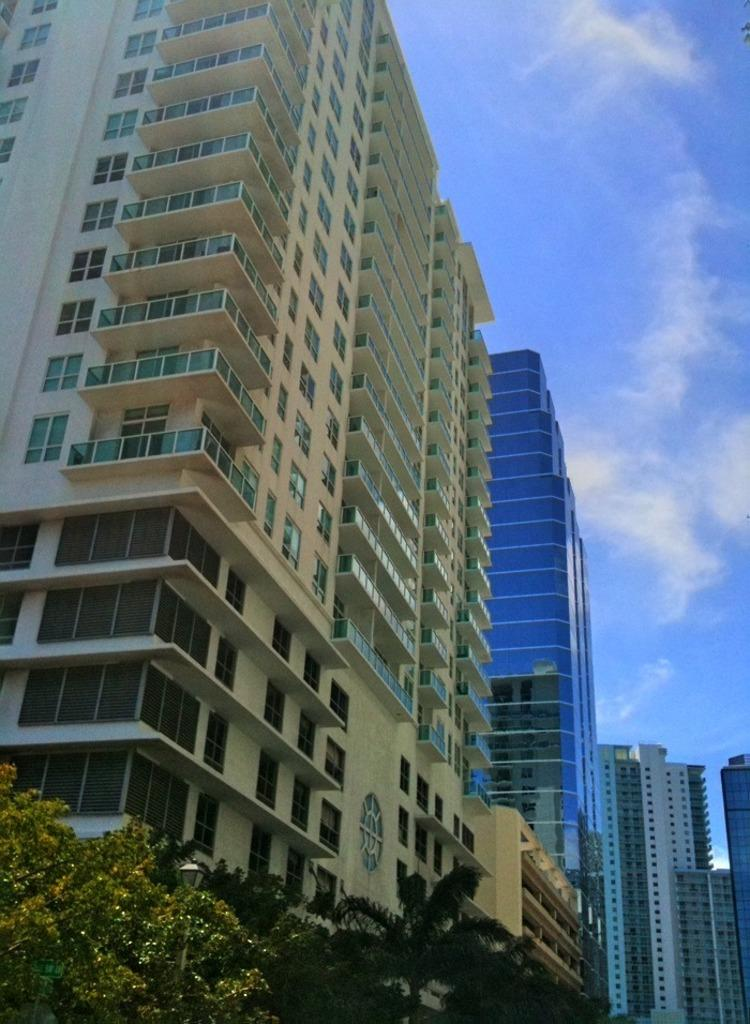What type of vegetation is present in the image? There are trees in the image. What is the color of the trees? The trees are green in color. What can be seen in the background of the image? There are buildings in the background of the image. What colors are the buildings? The buildings are white and cream in color. What is visible in the sky in the image? The sky is blue and white in color. Can you see a wrench being used on the trees in the image? There is no wrench present in the image, and no activity involving a wrench can be observed. 